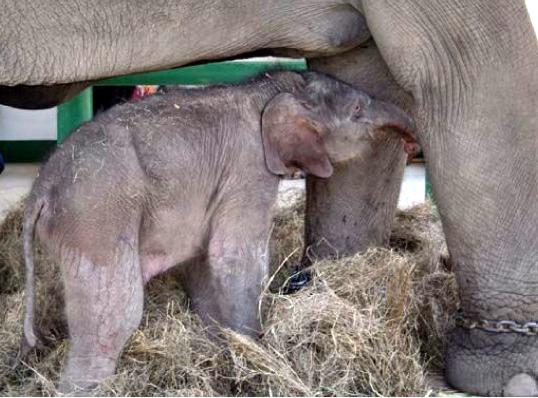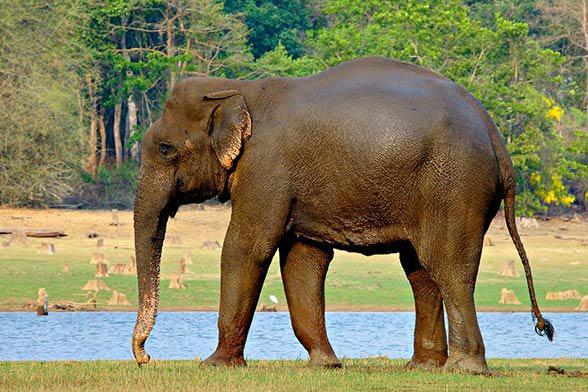The first image is the image on the left, the second image is the image on the right. Examine the images to the left and right. Is the description "One image features an elephant with tusks and a lowered trunk, and the other shows an elephant with tusks and a raised curled trunk." accurate? Answer yes or no. No. The first image is the image on the left, the second image is the image on the right. Given the left and right images, does the statement "Exactly two elephants are shown, one with its trunk hanging down, and one with its trunk curled up to its head, but both of them with tusks." hold true? Answer yes or no. No. 